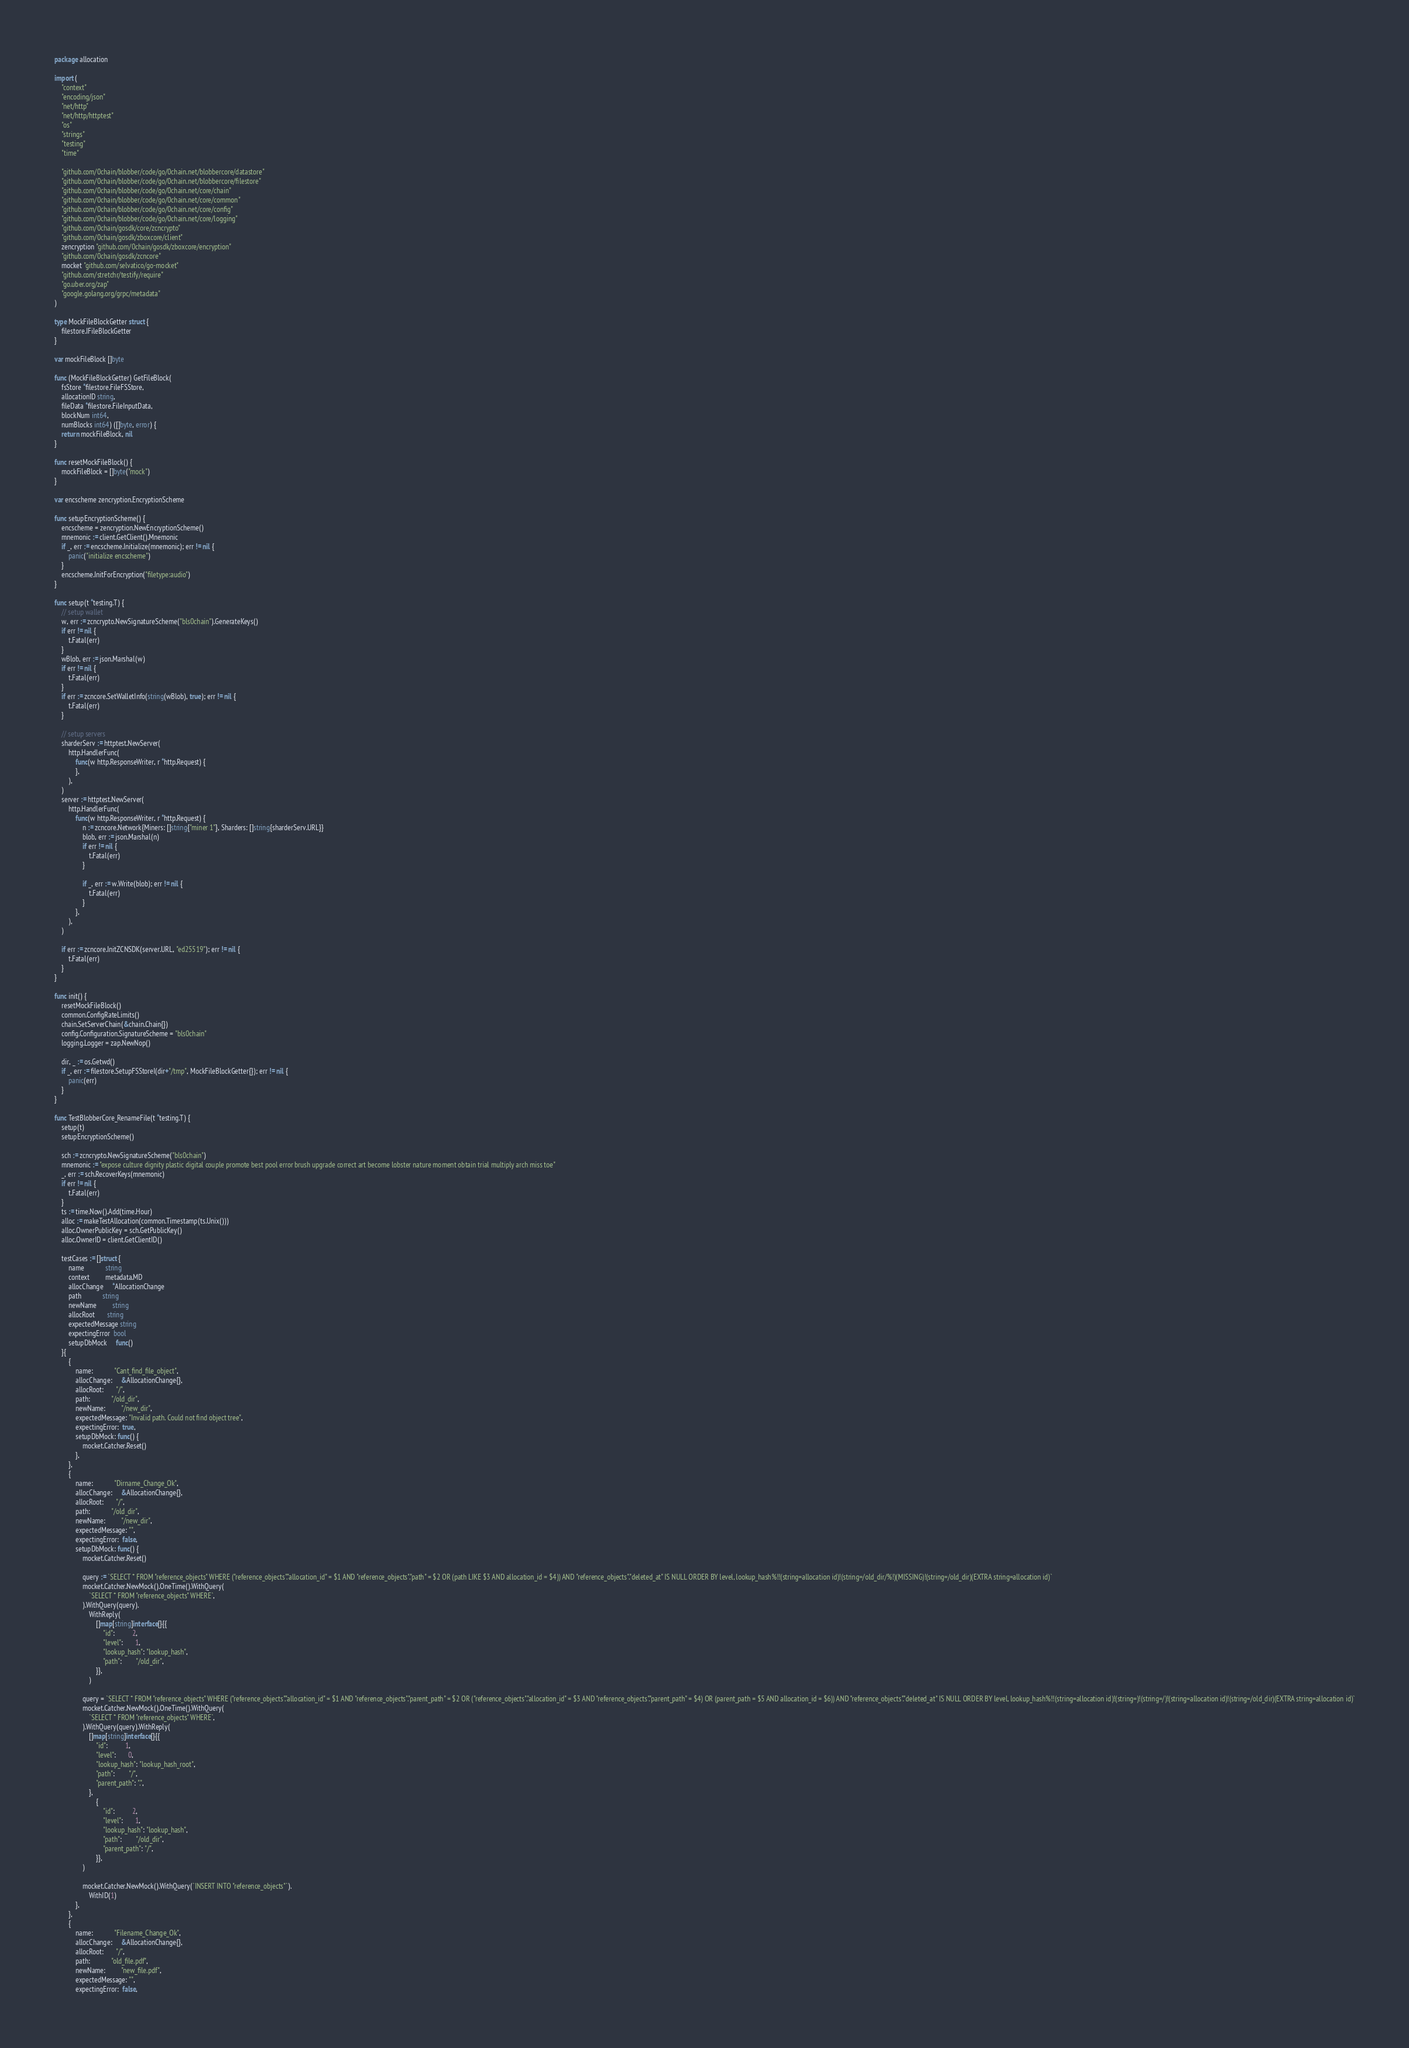Convert code to text. <code><loc_0><loc_0><loc_500><loc_500><_Go_>package allocation

import (
	"context"
	"encoding/json"
	"net/http"
	"net/http/httptest"
	"os"
	"strings"
	"testing"
	"time"

	"github.com/0chain/blobber/code/go/0chain.net/blobbercore/datastore"
	"github.com/0chain/blobber/code/go/0chain.net/blobbercore/filestore"
	"github.com/0chain/blobber/code/go/0chain.net/core/chain"
	"github.com/0chain/blobber/code/go/0chain.net/core/common"
	"github.com/0chain/blobber/code/go/0chain.net/core/config"
	"github.com/0chain/blobber/code/go/0chain.net/core/logging"
	"github.com/0chain/gosdk/core/zcncrypto"
	"github.com/0chain/gosdk/zboxcore/client"
	zencryption "github.com/0chain/gosdk/zboxcore/encryption"
	"github.com/0chain/gosdk/zcncore"
	mocket "github.com/selvatico/go-mocket"
	"github.com/stretchr/testify/require"
	"go.uber.org/zap"
	"google.golang.org/grpc/metadata"
)

type MockFileBlockGetter struct {
	filestore.IFileBlockGetter
}

var mockFileBlock []byte

func (MockFileBlockGetter) GetFileBlock(
	fsStore *filestore.FileFSStore,
	allocationID string,
	fileData *filestore.FileInputData,
	blockNum int64,
	numBlocks int64) ([]byte, error) {
	return mockFileBlock, nil
}

func resetMockFileBlock() {
	mockFileBlock = []byte("mock")
}

var encscheme zencryption.EncryptionScheme

func setupEncryptionScheme() {
	encscheme = zencryption.NewEncryptionScheme()
	mnemonic := client.GetClient().Mnemonic
	if _, err := encscheme.Initialize(mnemonic); err != nil {
		panic("initialize encscheme")
	}
	encscheme.InitForEncryption("filetype:audio")
}

func setup(t *testing.T) {
	// setup wallet
	w, err := zcncrypto.NewSignatureScheme("bls0chain").GenerateKeys()
	if err != nil {
		t.Fatal(err)
	}
	wBlob, err := json.Marshal(w)
	if err != nil {
		t.Fatal(err)
	}
	if err := zcncore.SetWalletInfo(string(wBlob), true); err != nil {
		t.Fatal(err)
	}

	// setup servers
	sharderServ := httptest.NewServer(
		http.HandlerFunc(
			func(w http.ResponseWriter, r *http.Request) {
			},
		),
	)
	server := httptest.NewServer(
		http.HandlerFunc(
			func(w http.ResponseWriter, r *http.Request) {
				n := zcncore.Network{Miners: []string{"miner 1"}, Sharders: []string{sharderServ.URL}}
				blob, err := json.Marshal(n)
				if err != nil {
					t.Fatal(err)
				}

				if _, err := w.Write(blob); err != nil {
					t.Fatal(err)
				}
			},
		),
	)

	if err := zcncore.InitZCNSDK(server.URL, "ed25519"); err != nil {
		t.Fatal(err)
	}
}

func init() {
	resetMockFileBlock()
	common.ConfigRateLimits()
	chain.SetServerChain(&chain.Chain{})
	config.Configuration.SignatureScheme = "bls0chain"
	logging.Logger = zap.NewNop()

	dir, _ := os.Getwd()
	if _, err := filestore.SetupFSStoreI(dir+"/tmp", MockFileBlockGetter{}); err != nil {
		panic(err)
	}
}

func TestBlobberCore_RenameFile(t *testing.T) {
	setup(t)
	setupEncryptionScheme()

	sch := zcncrypto.NewSignatureScheme("bls0chain")
	mnemonic := "expose culture dignity plastic digital couple promote best pool error brush upgrade correct art become lobster nature moment obtain trial multiply arch miss toe"
	_, err := sch.RecoverKeys(mnemonic)
	if err != nil {
		t.Fatal(err)
	}
	ts := time.Now().Add(time.Hour)
	alloc := makeTestAllocation(common.Timestamp(ts.Unix()))
	alloc.OwnerPublicKey = sch.GetPublicKey()
	alloc.OwnerID = client.GetClientID()

	testCases := []struct {
		name            string
		context         metadata.MD
		allocChange     *AllocationChange
		path            string
		newName         string
		allocRoot       string
		expectedMessage string
		expectingError  bool
		setupDbMock     func()
	}{
		{
			name:            "Cant_find_file_object",
			allocChange:     &AllocationChange{},
			allocRoot:       "/",
			path:            "/old_dir",
			newName:         "/new_dir",
			expectedMessage: "Invalid path. Could not find object tree",
			expectingError:  true,
			setupDbMock: func() {
				mocket.Catcher.Reset()
			},
		},
		{
			name:            "Dirname_Change_Ok",
			allocChange:     &AllocationChange{},
			allocRoot:       "/",
			path:            "/old_dir",
			newName:         "/new_dir",
			expectedMessage: "",
			expectingError:  false,
			setupDbMock: func() {
				mocket.Catcher.Reset()

				query := `SELECT * FROM "reference_objects" WHERE ("reference_objects"."allocation_id" = $1 AND "reference_objects"."path" = $2 OR (path LIKE $3 AND allocation_id = $4)) AND "reference_objects"."deleted_at" IS NULL ORDER BY level, lookup_hash%!!(string=allocation id)!(string=/old_dir/%!)(MISSING)!(string=/old_dir)(EXTRA string=allocation id)`
				mocket.Catcher.NewMock().OneTime().WithQuery(
					`SELECT * FROM "reference_objects" WHERE`,
				).WithQuery(query).
					WithReply(
						[]map[string]interface{}{{
							"id":          2,
							"level":       1,
							"lookup_hash": "lookup_hash",
							"path":        "/old_dir",
						}},
					)

				query = `SELECT * FROM "reference_objects" WHERE ("reference_objects"."allocation_id" = $1 AND "reference_objects"."parent_path" = $2 OR ("reference_objects"."allocation_id" = $3 AND "reference_objects"."parent_path" = $4) OR (parent_path = $5 AND allocation_id = $6)) AND "reference_objects"."deleted_at" IS NULL ORDER BY level, lookup_hash%!!(string=allocation id)!(string=)!(string=/)!(string=allocation id)!(string=/old_dir)(EXTRA string=allocation id)`
				mocket.Catcher.NewMock().OneTime().WithQuery(
					`SELECT * FROM "reference_objects" WHERE`,
				).WithQuery(query).WithReply(
					[]map[string]interface{}{{
						"id":          1,
						"level":       0,
						"lookup_hash": "lookup_hash_root",
						"path":        "/",
						"parent_path": ".",
					},
						{
							"id":          2,
							"level":       1,
							"lookup_hash": "lookup_hash",
							"path":        "/old_dir",
							"parent_path": "/",
						}},
				)

				mocket.Catcher.NewMock().WithQuery(`INSERT INTO "reference_objects"`).
					WithID(1)
			},
		},
		{
			name:            "Filename_Change_Ok",
			allocChange:     &AllocationChange{},
			allocRoot:       "/",
			path:            "old_file.pdf",
			newName:         "new_file.pdf",
			expectedMessage: "",
			expectingError:  false,</code> 